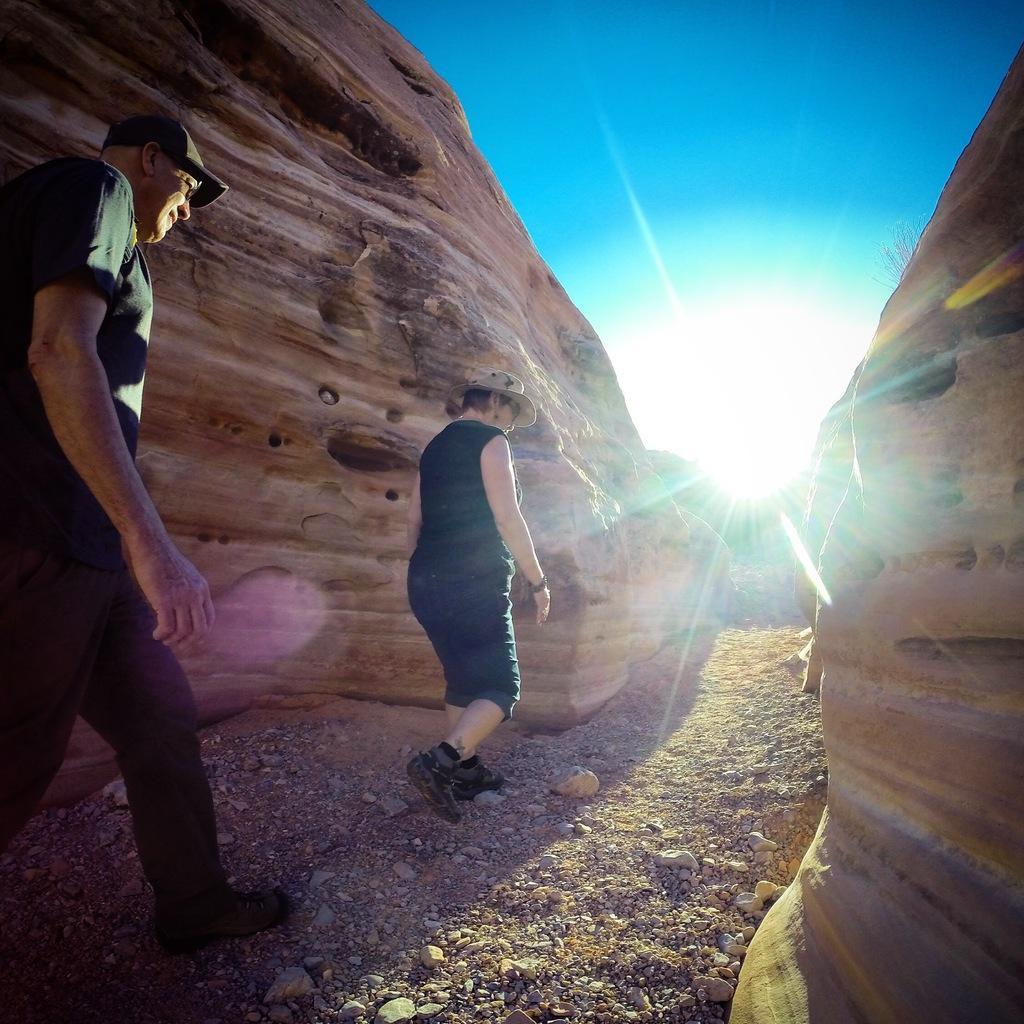Could you give a brief overview of what you see in this image? In this image, we can see a man and a lady walking and wearing a cap and a hat. In the background, we can see rocks and there is a sunlight. At the bottom, there is ground. 